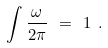<formula> <loc_0><loc_0><loc_500><loc_500>\int \frac { \omega } { 2 \pi } \ = \ 1 \ .</formula> 